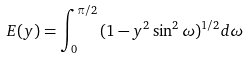Convert formula to latex. <formula><loc_0><loc_0><loc_500><loc_500>E ( y ) = \int _ { 0 } ^ { \pi / 2 } { ( 1 - y ^ { 2 } \sin ^ { 2 } \omega ) ^ { 1 / 2 } d \omega }</formula> 